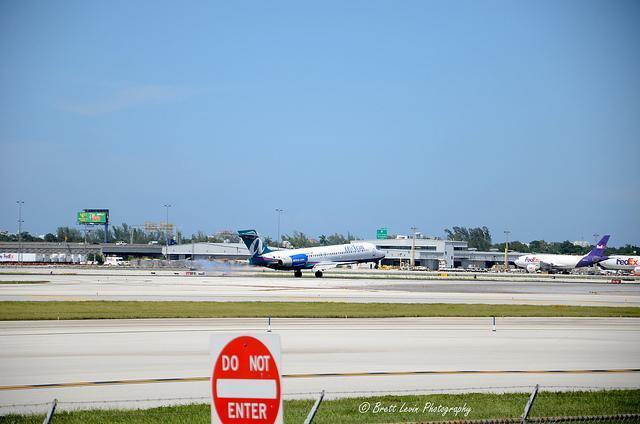How many FedEx planes are there?
Give a very brief answer. 2. How many green keyboards are on the table?
Give a very brief answer. 0. 